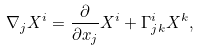Convert formula to latex. <formula><loc_0><loc_0><loc_500><loc_500>\nabla _ { j } X ^ { i } = \frac { \partial } { \partial x _ { j } } X ^ { i } + \Gamma ^ { i } _ { j k } X ^ { k } ,</formula> 